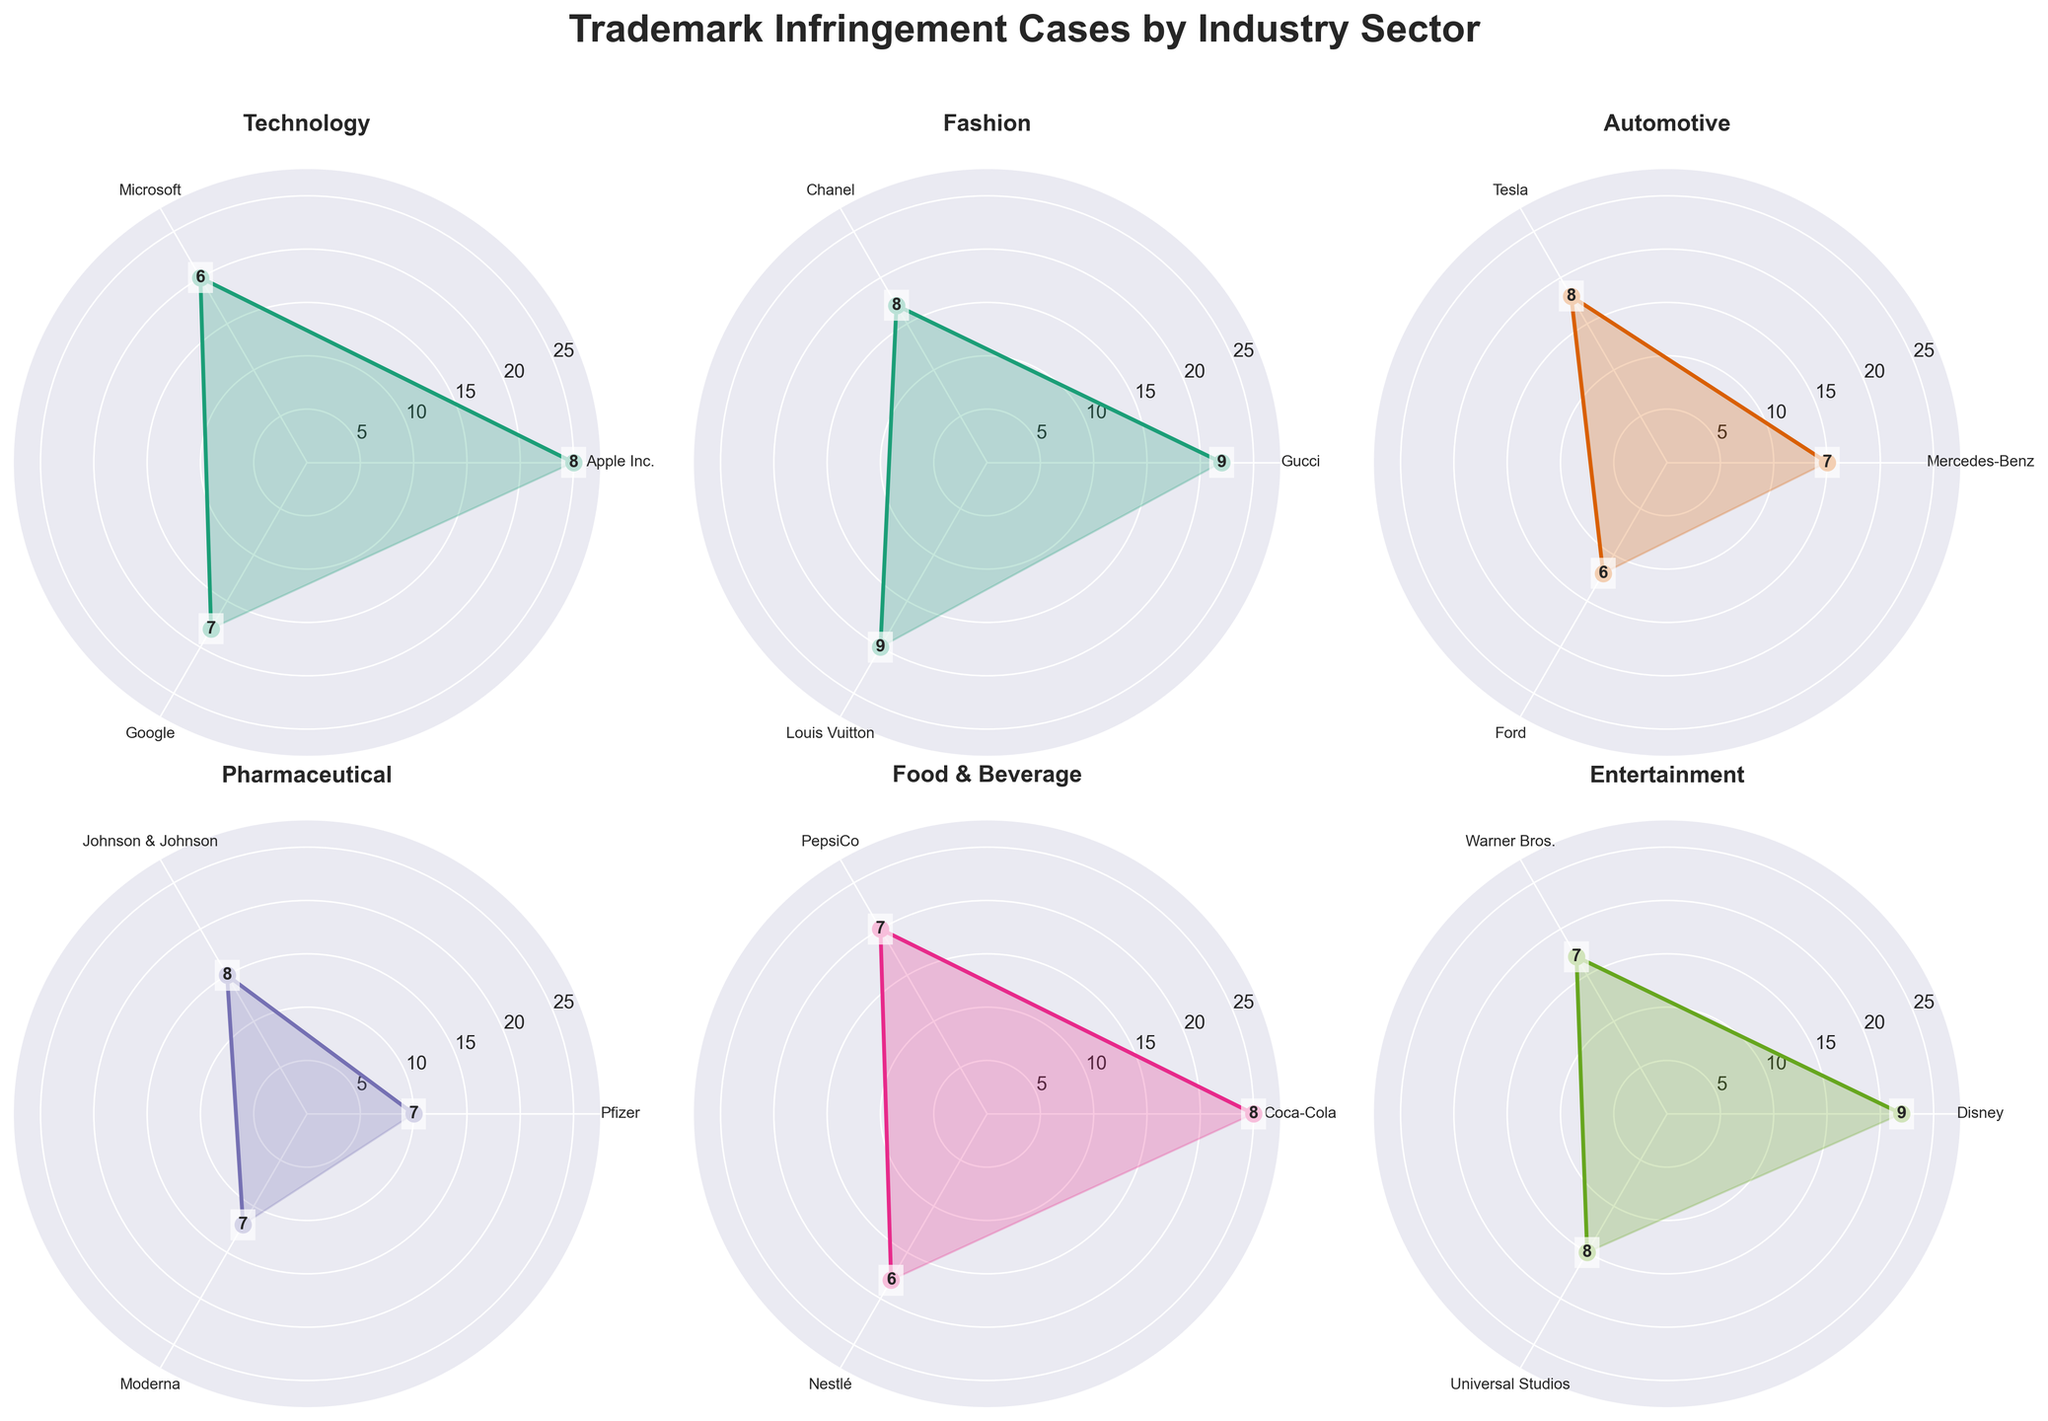What's the title of the figure? The title is located at the top of the figure and provides an overview of what the figure represents. The phrase "Trademark Infringement Cases by Industry Sector" is clearly visible.
Answer: Trademark Infringement Cases by Industry Sector How many industry sectors are represented? Each subplot in the figure represents a different industry sector. By counting the number of subplots, we can determine the number of sectors.
Answer: 6 What is the frequency range represented in the Technology sector? To find the range of frequency values in the Technology sector, locate the Technology subplot and observe the minimum and maximum frequency values plotted.
Answer: 18 to 25 Which entity in the Fashion sector has the highest severity? Locate the Fashion sector subplot, then identify which entity has the highest severity label inside the plot. Gucci, Chanel, and Louis Vuitton are visible, and the highest severity is marked.
Answer: Gucci and Louis Vuitton Are there any sectors where the maximum frequency for any entity is equal to the overall maximum frequency across all sectors? Check the frequency values across all subplots to see if any sector reaches the highest frequency value of 25, which is the overall maximum. The Technology and Food & Beverage sectors both contain entities with this maximum frequency value.
Answer: Yes Which entity in the Automotive sector has the lowest frequency? In the Automotive sector subplot, observe the frequency values for all entities and identify the one with the lowest frequency. In this case, the associated frequencies for Mercedes-Benz, Tesla, and Ford show that Ford has the lowest.
Answer: Ford Compare the severity of Disney in the Entertainment sector with that of Chanel in the Fashion sector. Which one is higher? Find the subplots for both Entertainment and Fashion sectors, then compare the severity values for Disney and Chanel. Disney and Chanel both represent high severity levels, but we need to compare the values directly.
Answer: Disney How does the average severity value in the Pharmaceutical sector compare to that in the Automotive sector? Calculate the average severity for both sectors by adding their severity values and dividing by the number of entities in each sector. For Pharmaceuticals (Pfizer: 7, Johnson & Johnson: 8, Moderna: 7) and Automotive (Mercedes-Benz: 7, Tesla: 8, Ford: 6), calculate the averages respectively.
Answer: Automotive: 7; Pharmaceutical: 7.33 What is the median frequency value in the Food & Beverage sector? The median is the middle value when all values are sorted. For the Food & Beverage sector, sort the frequency values (Coca-Cola: 25, PepsiCo: 20, Nestlé: 18) and find the middle value. Set the frequency array in ascending order and locate the median.
Answer: 20 